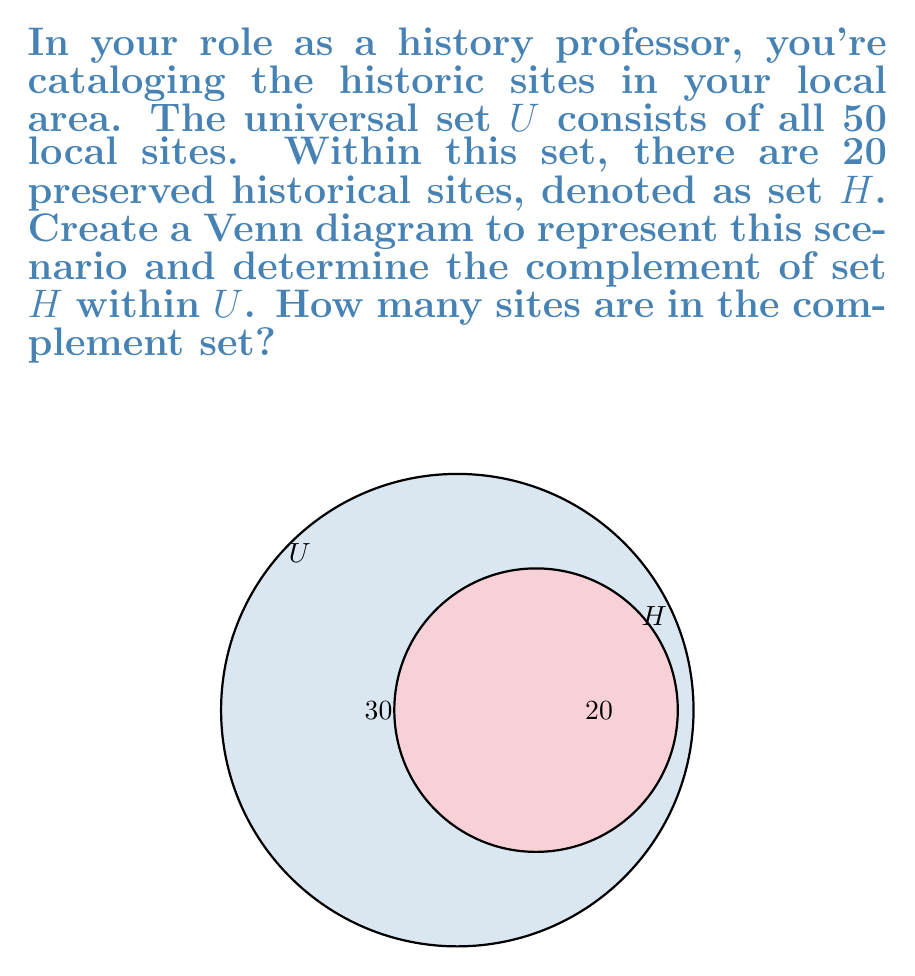Help me with this question. To solve this problem, let's follow these steps:

1) First, let's understand what the complement of a set means. The complement of set $H$ within the universal set $U$, denoted as $H^c$ or $U \setminus H$, consists of all elements in $U$ that are not in $H$.

2) We are given:
   - The universal set $U$ contains 50 sites in total.
   - Set $H$ contains 20 preserved historical sites.

3) To find the complement, we need to subtract the number of elements in $H$ from the total number of elements in $U$:

   $$|H^c| = |U| - |H|$$

   Where $|X|$ denotes the number of elements in set $X$.

4) Substituting the values:

   $$|H^c| = 50 - 20 = 30$$

5) Therefore, there are 30 sites in the complement set $H^c$.

This result is visually represented in the Venn diagram, where the area outside the $H$ circle but inside the $U$ circle represents the complement set, labeled with "30".
Answer: 30 sites 